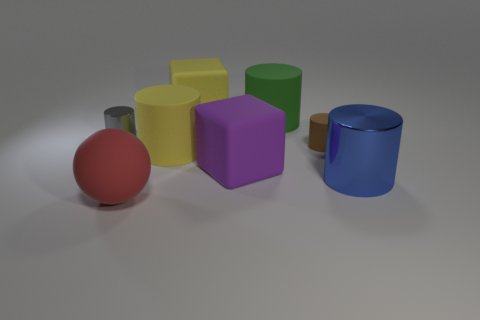There is another large thing that is the same shape as the big purple matte object; what is it made of?
Offer a terse response. Rubber. There is a tiny matte thing right of the large red sphere; is it the same color as the tiny metallic thing that is in front of the large yellow cube?
Provide a succinct answer. No. Is there another red matte object that has the same size as the red object?
Your response must be concise. No. There is a thing that is left of the big yellow cylinder and to the right of the tiny shiny cylinder; what material is it?
Provide a short and direct response. Rubber. How many metallic objects are either tiny red objects or yellow cubes?
Make the answer very short. 0. There is a large purple object that is the same material as the sphere; what is its shape?
Provide a short and direct response. Cube. How many big matte objects are behind the blue metal thing and in front of the yellow block?
Your answer should be compact. 3. Is there any other thing that is the same shape as the brown thing?
Your response must be concise. Yes. There is a metallic cylinder in front of the small brown matte cylinder; how big is it?
Give a very brief answer. Large. There is a cube that is in front of the small object that is on the right side of the matte sphere; what is its material?
Give a very brief answer. Rubber. 